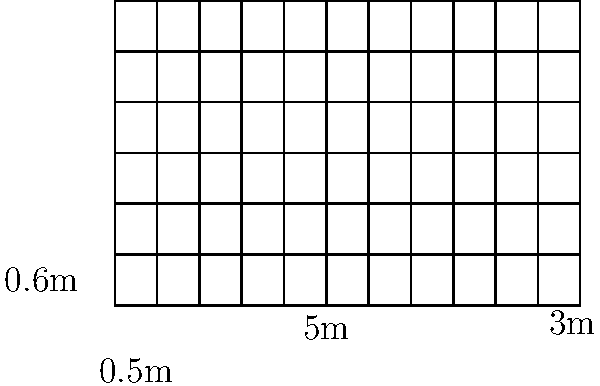You're working on a period film set and need to wallpaper a rectangular wall. The wall measures 5m wide by 3m high, and the wallpaper pattern repeats every 0.5m horizontally and 0.6m vertically. Assuming you need to match the pattern perfectly and account for 10% waste, how many square meters of wallpaper should you order? Let's break this down step-by-step:

1. Calculate the area of the wall:
   $A_{wall} = 5m \times 3m = 15m^2$

2. Determine the number of complete pattern repeats needed:
   Horizontal repeats: $5m \div 0.5m = 10$
   Vertical repeats: $3m \div 0.6m = 5$

3. Calculate the area of wallpaper needed for complete patterns:
   $A_{pattern} = 10 \times 0.5m \times 5 \times 0.6m = 15m^2$

4. The area needed matches the wall area, but we need to account for waste:
   $A_{total} = A_{pattern} \times 1.10$ (10% waste)
   $A_{total} = 15m^2 \times 1.10 = 16.5m^2$

Therefore, you should order 16.5 square meters of wallpaper to cover the wall with the given pattern and account for waste.
Answer: 16.5m² 